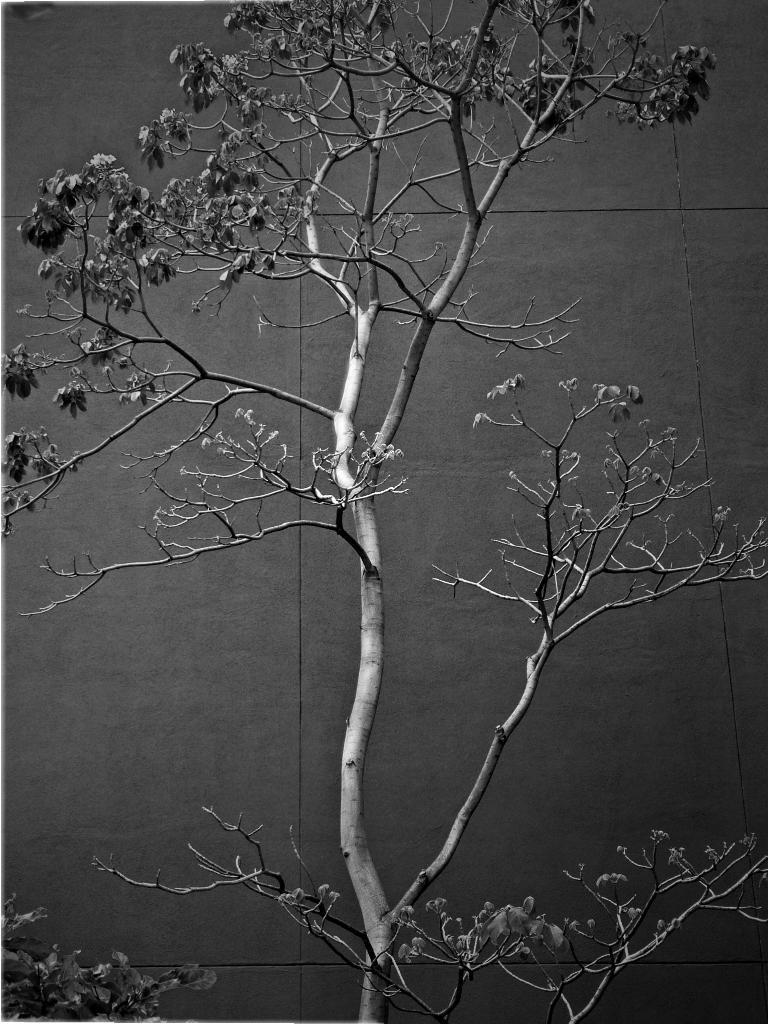Please provide a concise description of this image. This image consists of a plant. In the background, we can see a wall. 